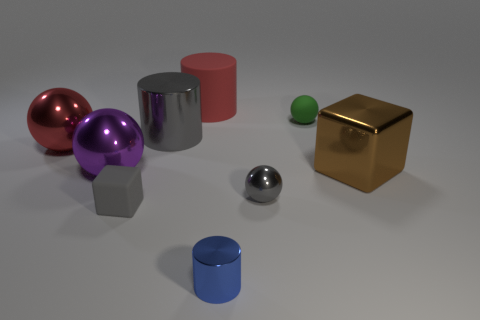Add 1 small blue things. How many objects exist? 10 Subtract all small rubber spheres. How many spheres are left? 3 Subtract all red spheres. How many spheres are left? 3 Subtract all blocks. How many objects are left? 7 Add 5 cyan balls. How many cyan balls exist? 5 Subtract 0 cyan cylinders. How many objects are left? 9 Subtract all purple cylinders. Subtract all brown spheres. How many cylinders are left? 3 Subtract all gray shiny spheres. Subtract all blue shiny things. How many objects are left? 7 Add 4 big gray metal things. How many big gray metal things are left? 5 